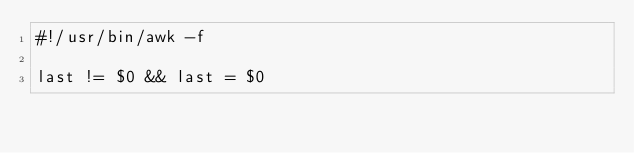Convert code to text. <code><loc_0><loc_0><loc_500><loc_500><_Awk_>#!/usr/bin/awk -f

last != $0 && last = $0</code> 